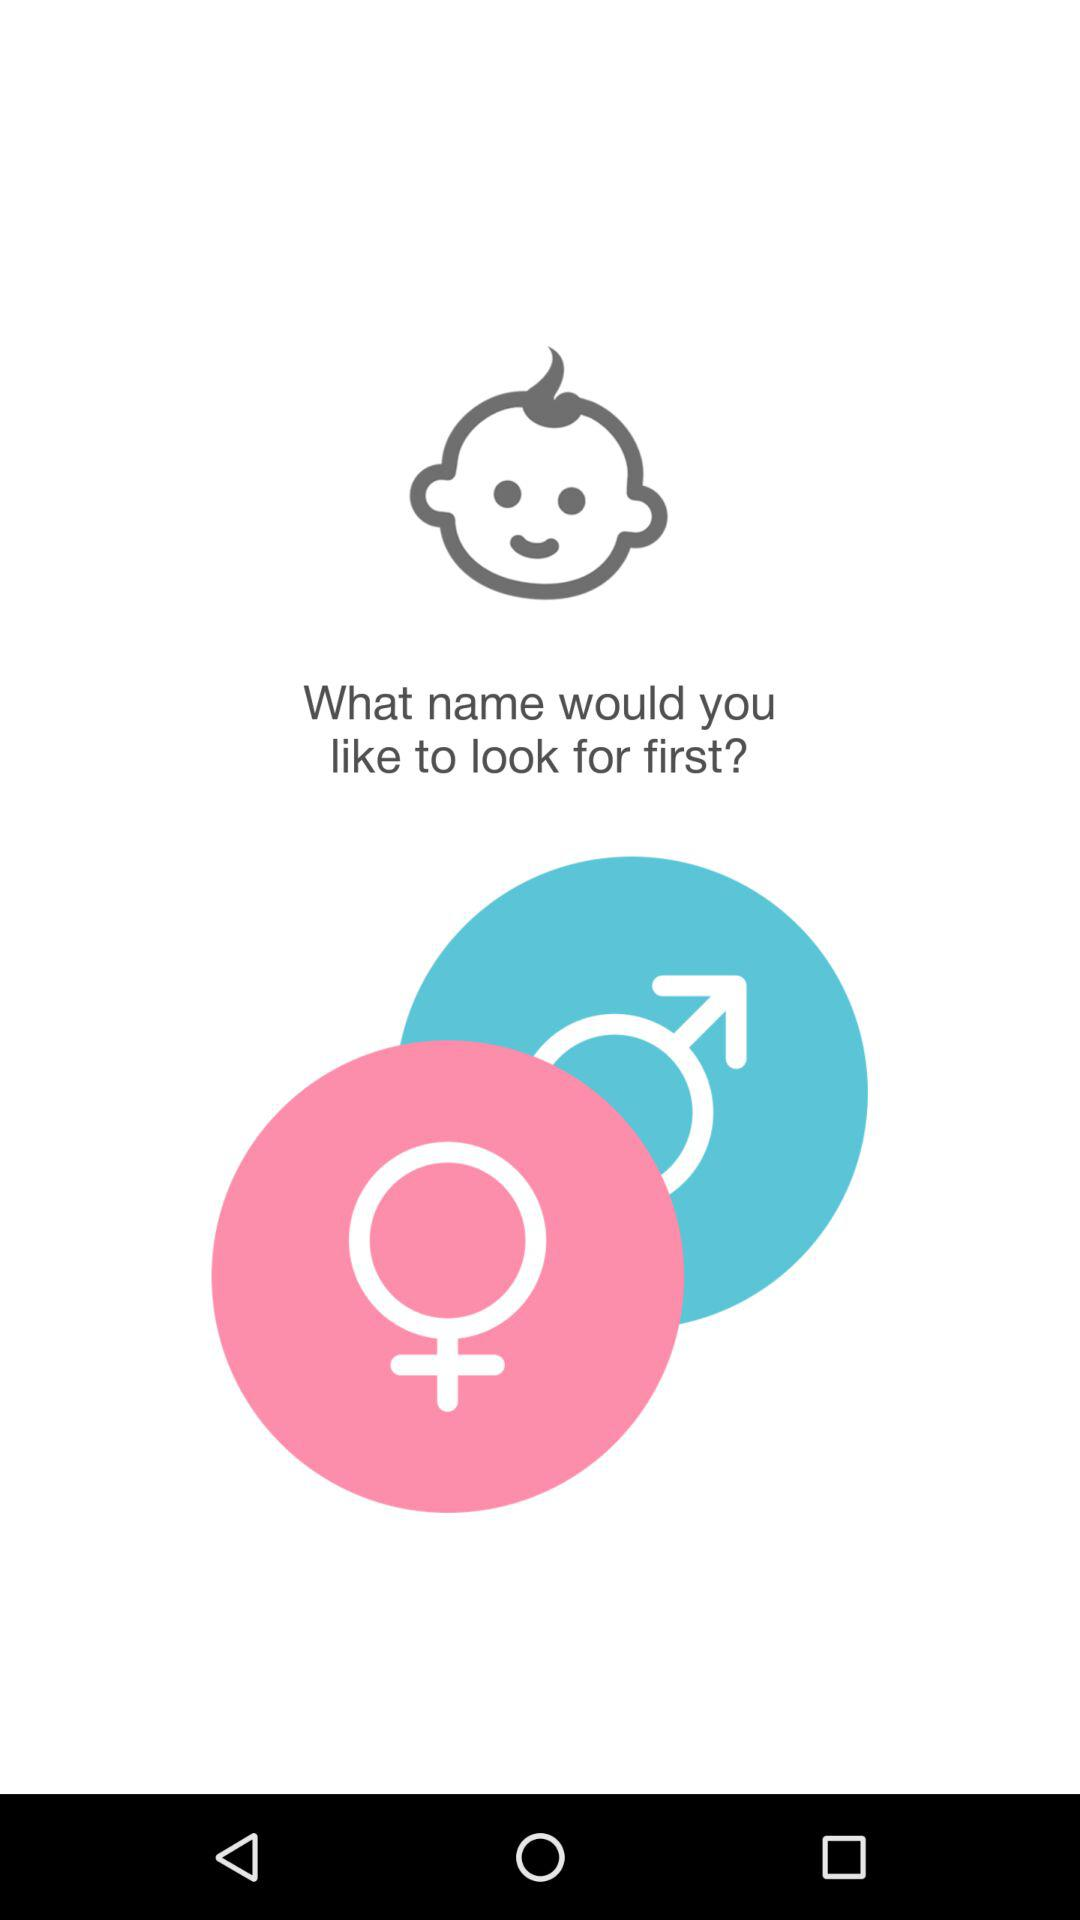How many symbols are not babies?
Answer the question using a single word or phrase. 2 